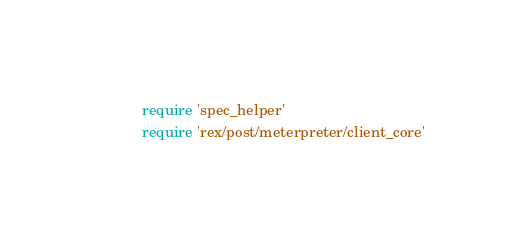Convert code to text. <code><loc_0><loc_0><loc_500><loc_500><_Ruby_>require 'spec_helper'
require 'rex/post/meterpreter/client_core'
</code> 